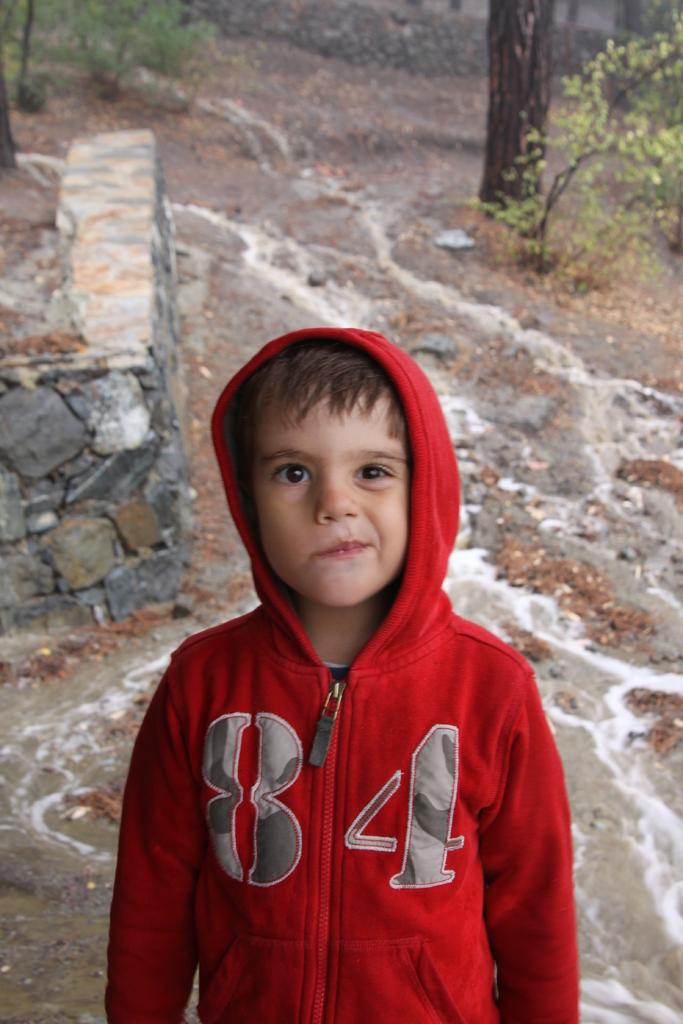<image>
Present a compact description of the photo's key features. A boy wearing a red jacket with the numbers 84 on the front. 